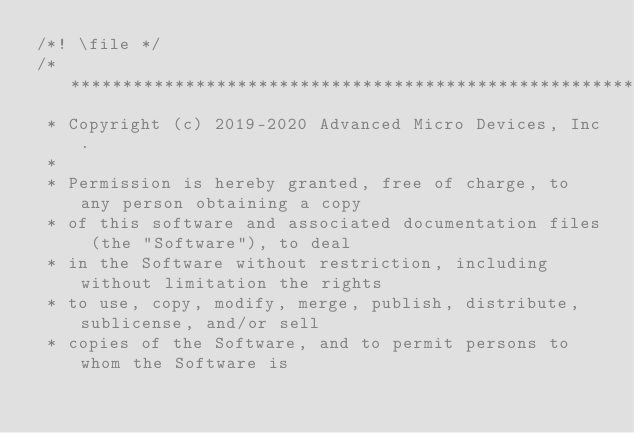Convert code to text. <code><loc_0><loc_0><loc_500><loc_500><_C++_>/*! \file */
/* ************************************************************************
 * Copyright (c) 2019-2020 Advanced Micro Devices, Inc.
 *
 * Permission is hereby granted, free of charge, to any person obtaining a copy
 * of this software and associated documentation files (the "Software"), to deal
 * in the Software without restriction, including without limitation the rights
 * to use, copy, modify, merge, publish, distribute, sublicense, and/or sell
 * copies of the Software, and to permit persons to whom the Software is</code> 